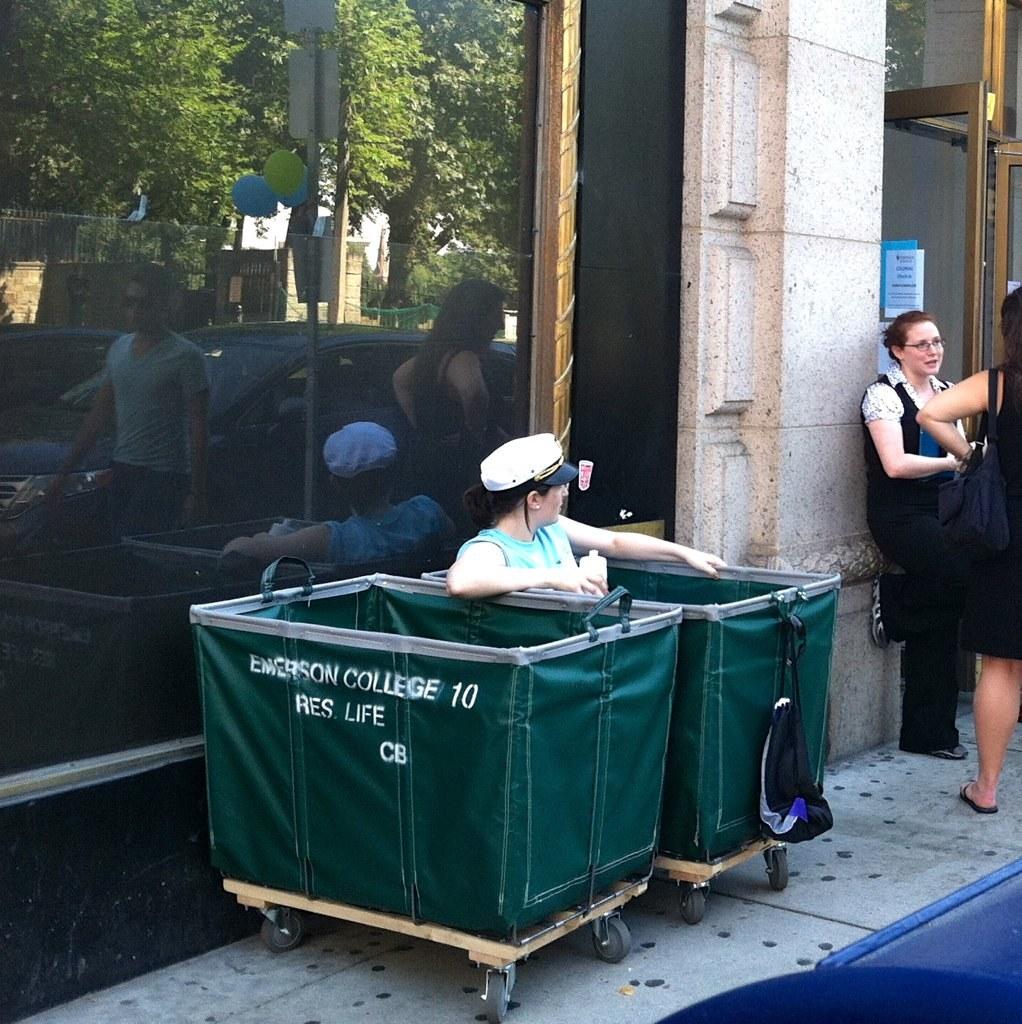Is this a dump bin?
Your answer should be very brief. Answering does not require reading text in the image. What college are the bins from?
Offer a very short reply. Emerson college. 